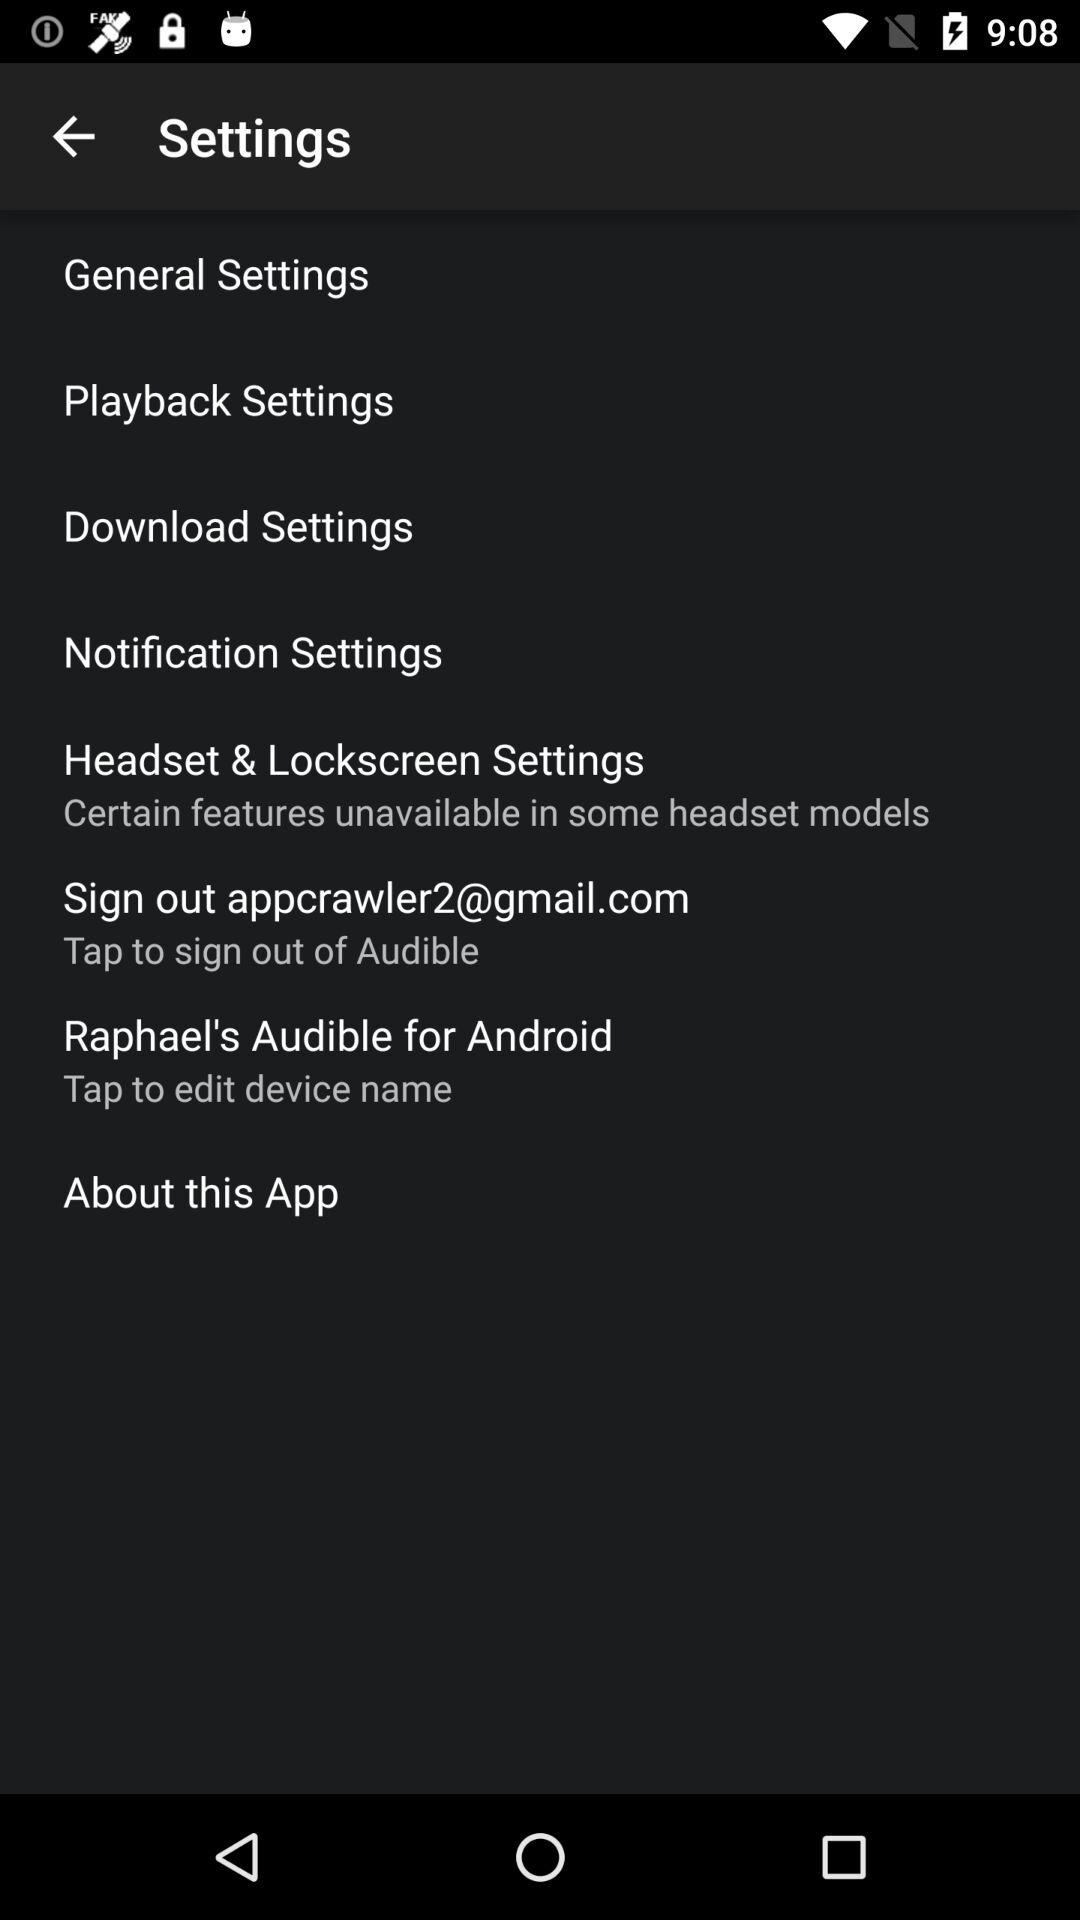What is the email address? The email address is appcrawler2@gmail.com. 